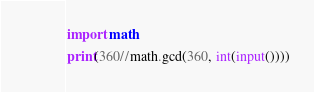<code> <loc_0><loc_0><loc_500><loc_500><_Cython_>import math
print(360//math.gcd(360, int(input())))</code> 